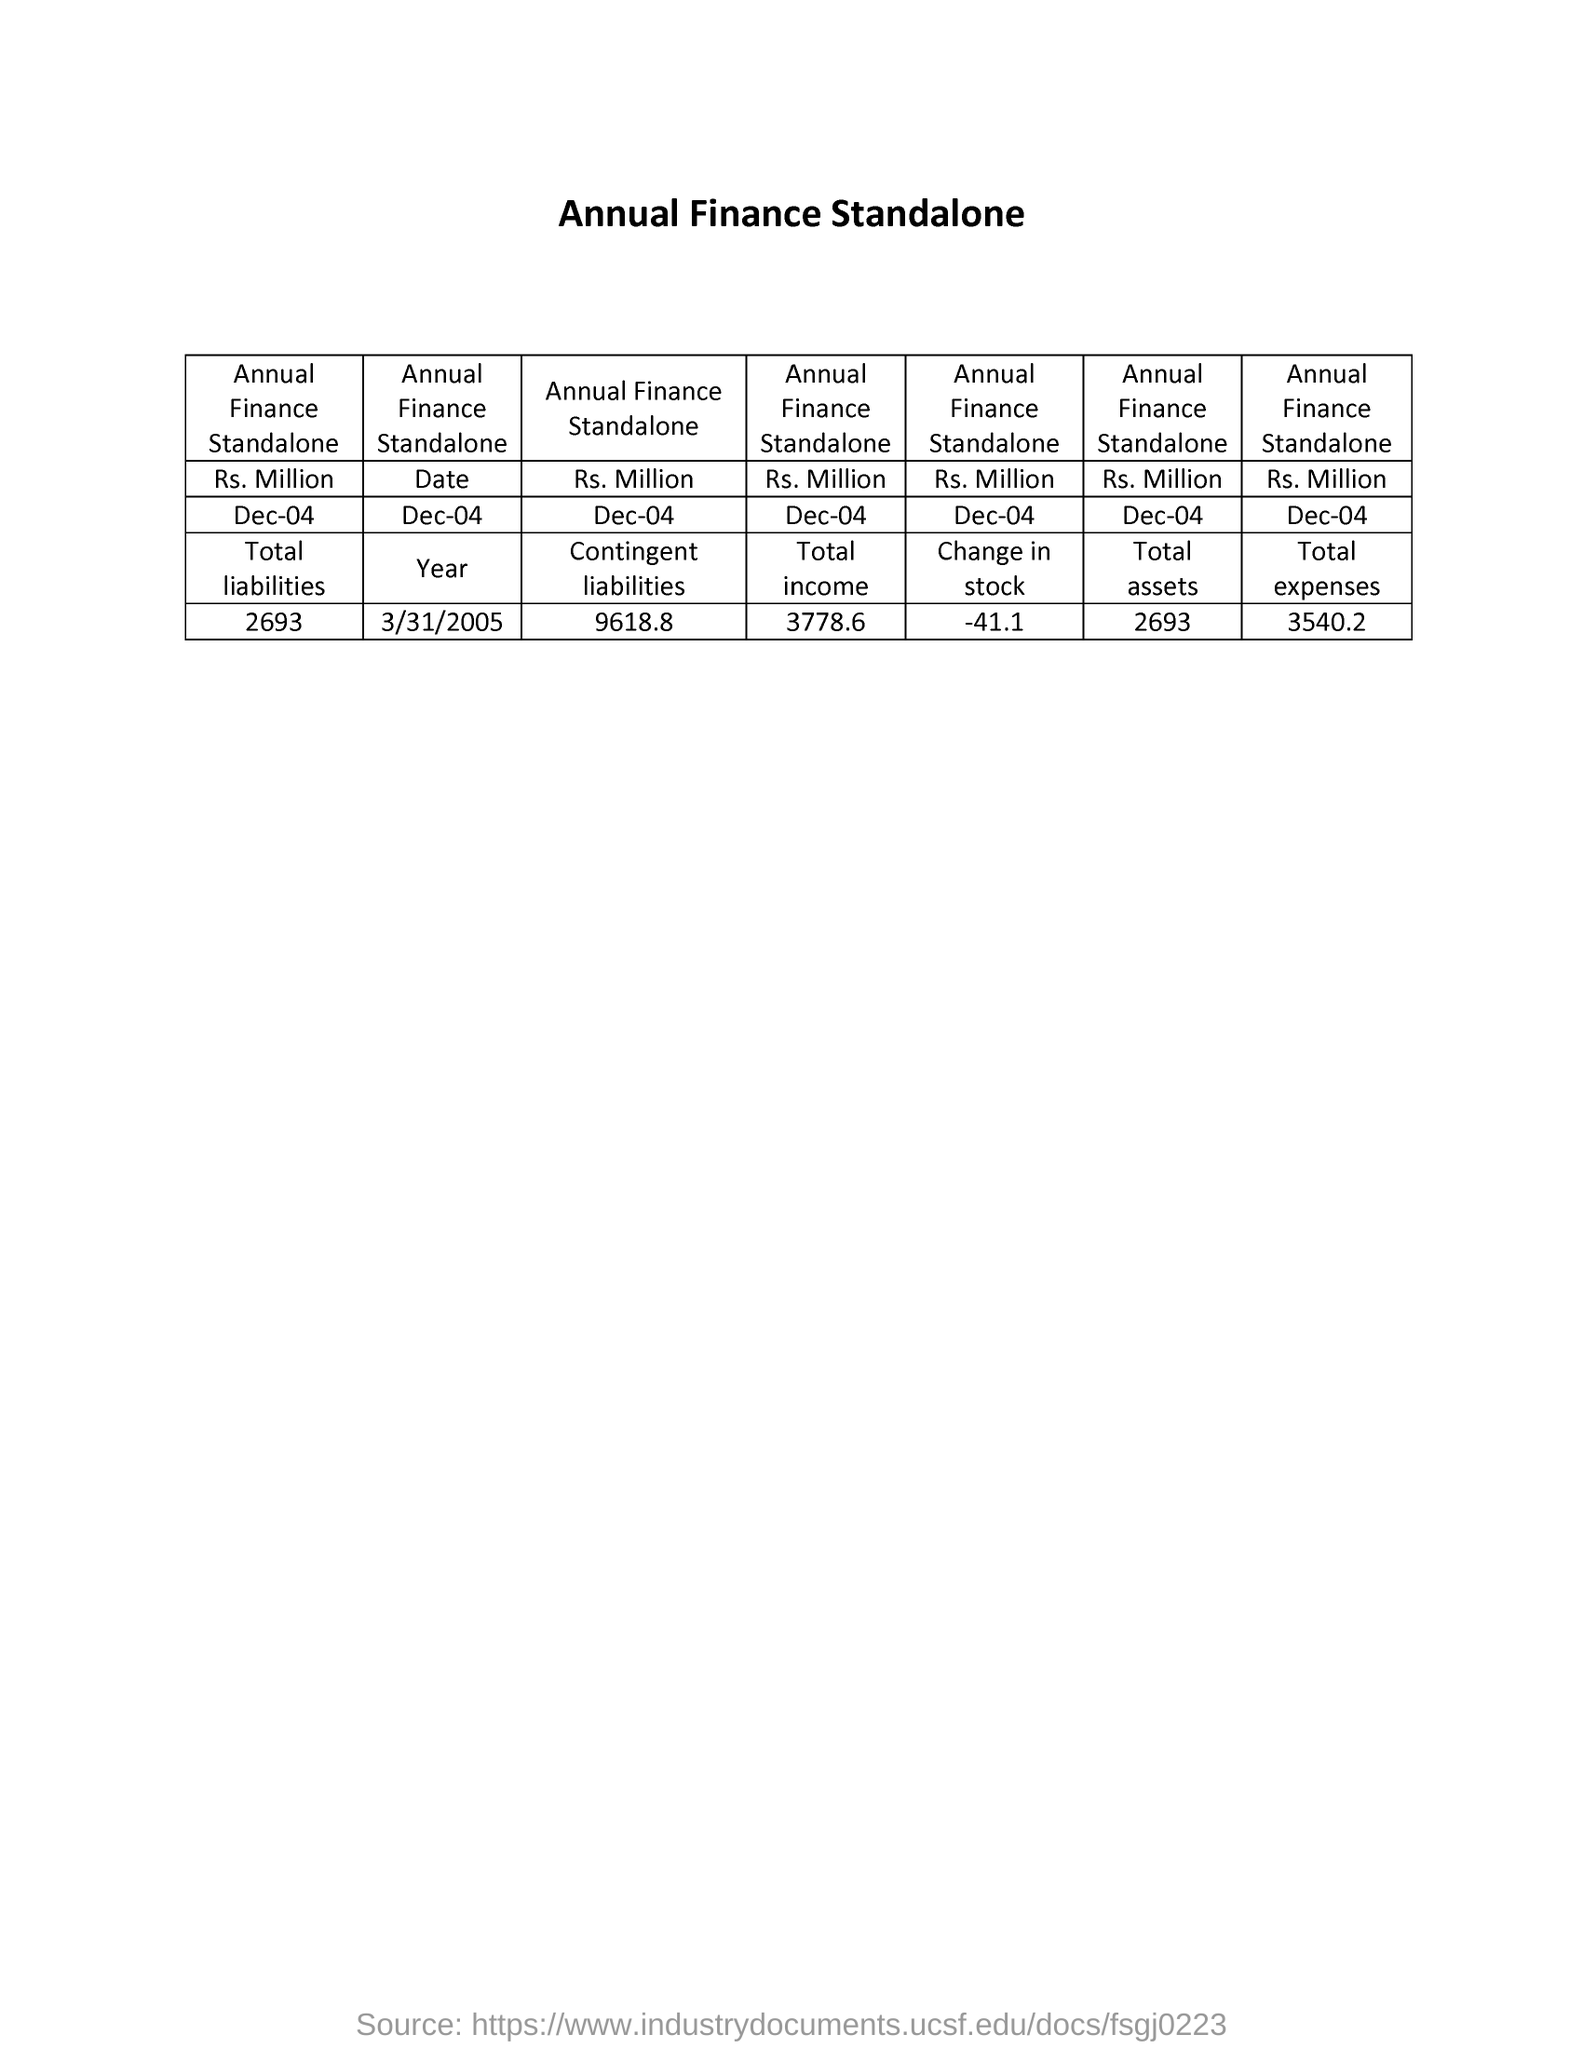Mention a couple of crucial points in this snapshot. As of December 4, the stock of annual finance standalone for the year ending 2022 was -41.1 million. The total assets of the annual finance standalone for the year ending December 2004 were Rs. 2,693 million. The total liabilities of the annual finance standalone as of December 4, 2026, were Rs. 2693 million. The total expenses for the annual finance standalone for the year ending December 4th amounted to Rs. 3540.2 million. As of December 2004, the total income of the annual finance standalone was Rs 3778.6 million. 